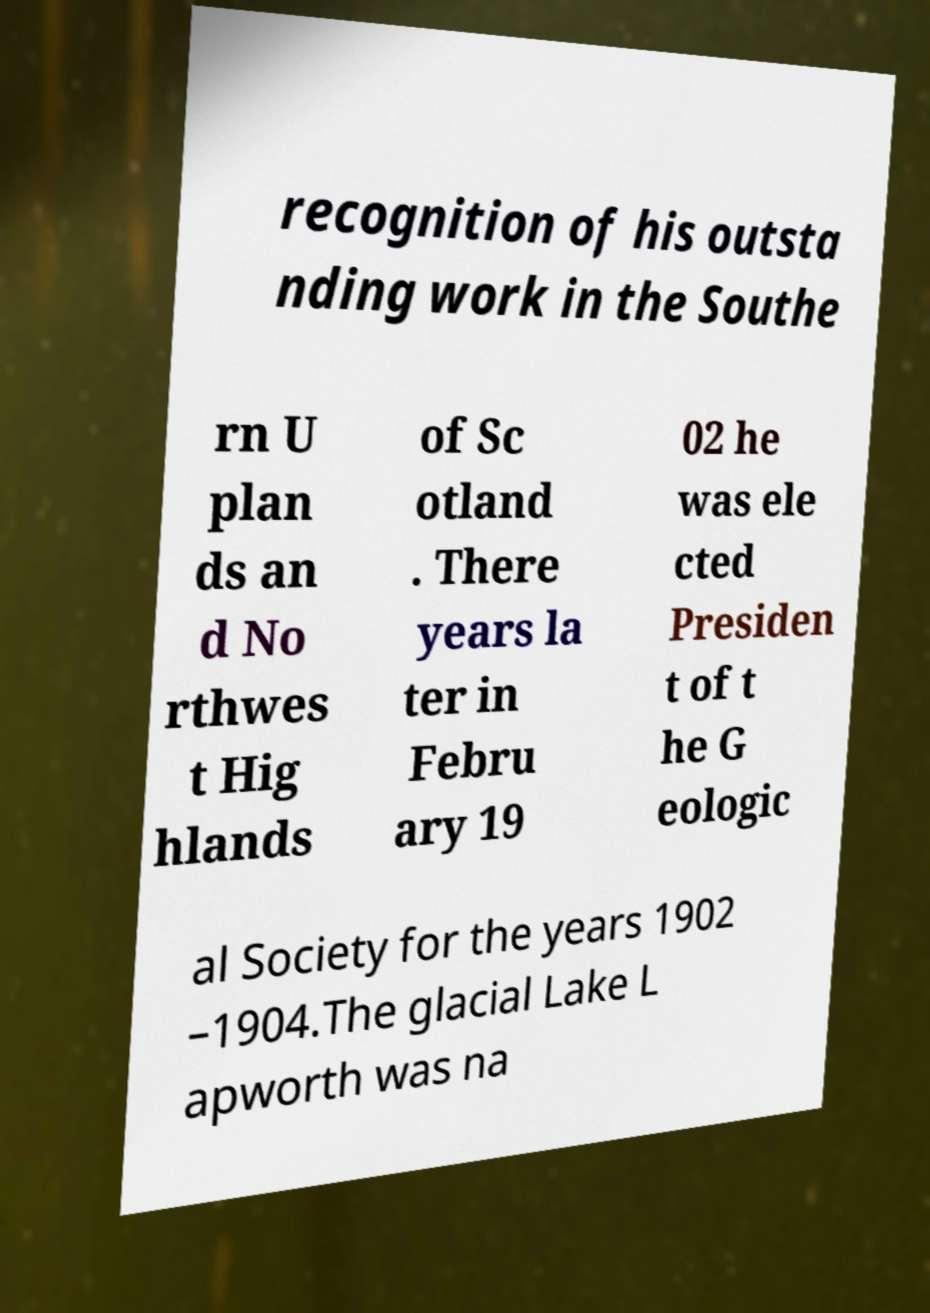Can you accurately transcribe the text from the provided image for me? recognition of his outsta nding work in the Southe rn U plan ds an d No rthwes t Hig hlands of Sc otland . There years la ter in Febru ary 19 02 he was ele cted Presiden t of t he G eologic al Society for the years 1902 –1904.The glacial Lake L apworth was na 